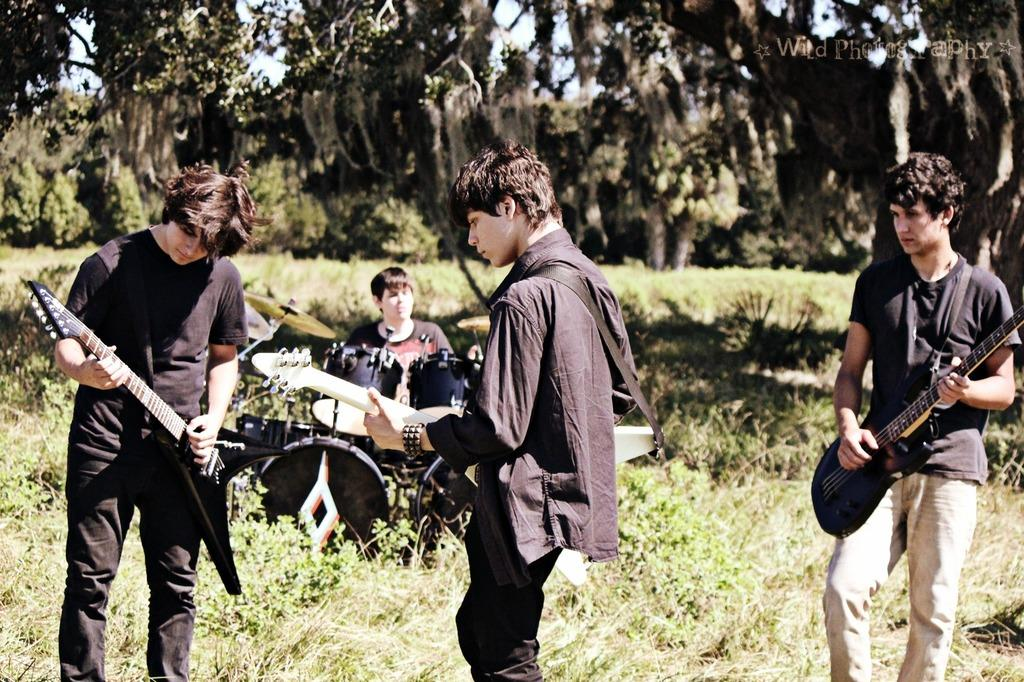How many people are in the image? There are four persons in the image. What are the persons doing in the image? The persons are playing musical instruments. Can you identify any specific musical instrument in the image? Yes, there is a drum in the image. What is the position of one of the persons in the image? One person is sitting on a chair. What can be seen in the background of the image? There are trees in the background of the image. What type of ring can be seen on the side of the drum in the image? There is no ring visible on the side of the drum in the image. How much salt is present on the chair where the person is sitting? There is no salt present in the image, and the person sitting on the chair is not interacting with any salt. 